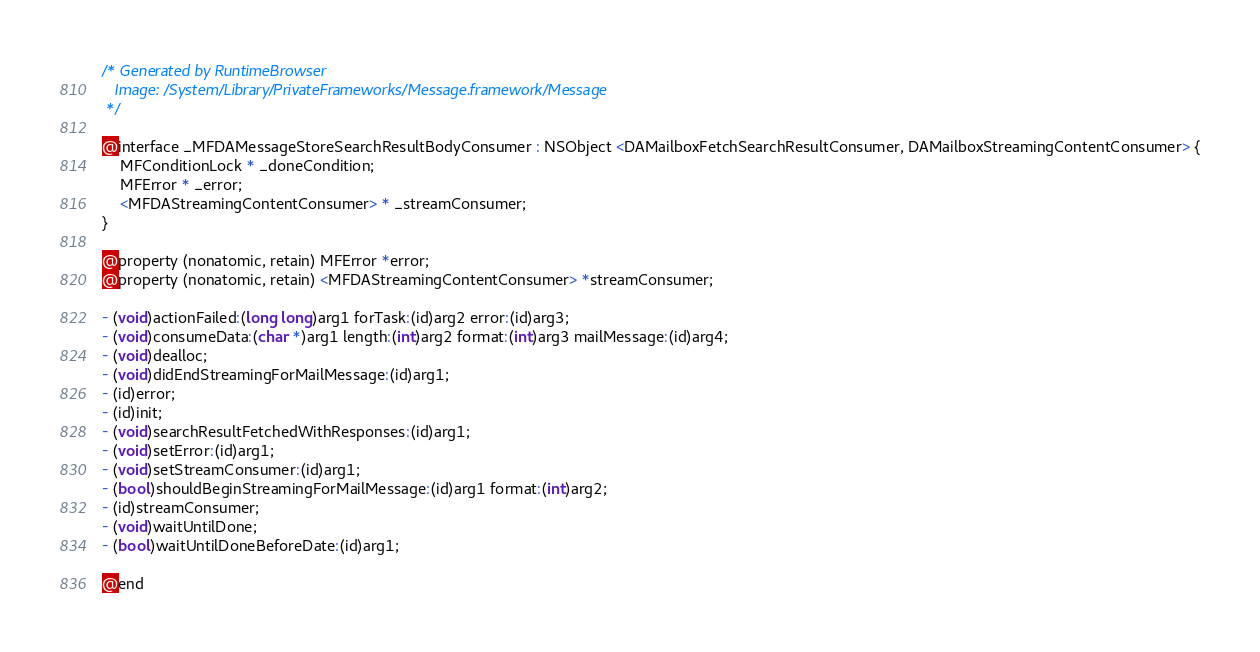<code> <loc_0><loc_0><loc_500><loc_500><_C_>/* Generated by RuntimeBrowser
   Image: /System/Library/PrivateFrameworks/Message.framework/Message
 */

@interface _MFDAMessageStoreSearchResultBodyConsumer : NSObject <DAMailboxFetchSearchResultConsumer, DAMailboxStreamingContentConsumer> {
    MFConditionLock * _doneCondition;
    MFError * _error;
    <MFDAStreamingContentConsumer> * _streamConsumer;
}

@property (nonatomic, retain) MFError *error;
@property (nonatomic, retain) <MFDAStreamingContentConsumer> *streamConsumer;

- (void)actionFailed:(long long)arg1 forTask:(id)arg2 error:(id)arg3;
- (void)consumeData:(char *)arg1 length:(int)arg2 format:(int)arg3 mailMessage:(id)arg4;
- (void)dealloc;
- (void)didEndStreamingForMailMessage:(id)arg1;
- (id)error;
- (id)init;
- (void)searchResultFetchedWithResponses:(id)arg1;
- (void)setError:(id)arg1;
- (void)setStreamConsumer:(id)arg1;
- (bool)shouldBeginStreamingForMailMessage:(id)arg1 format:(int)arg2;
- (id)streamConsumer;
- (void)waitUntilDone;
- (bool)waitUntilDoneBeforeDate:(id)arg1;

@end
</code> 